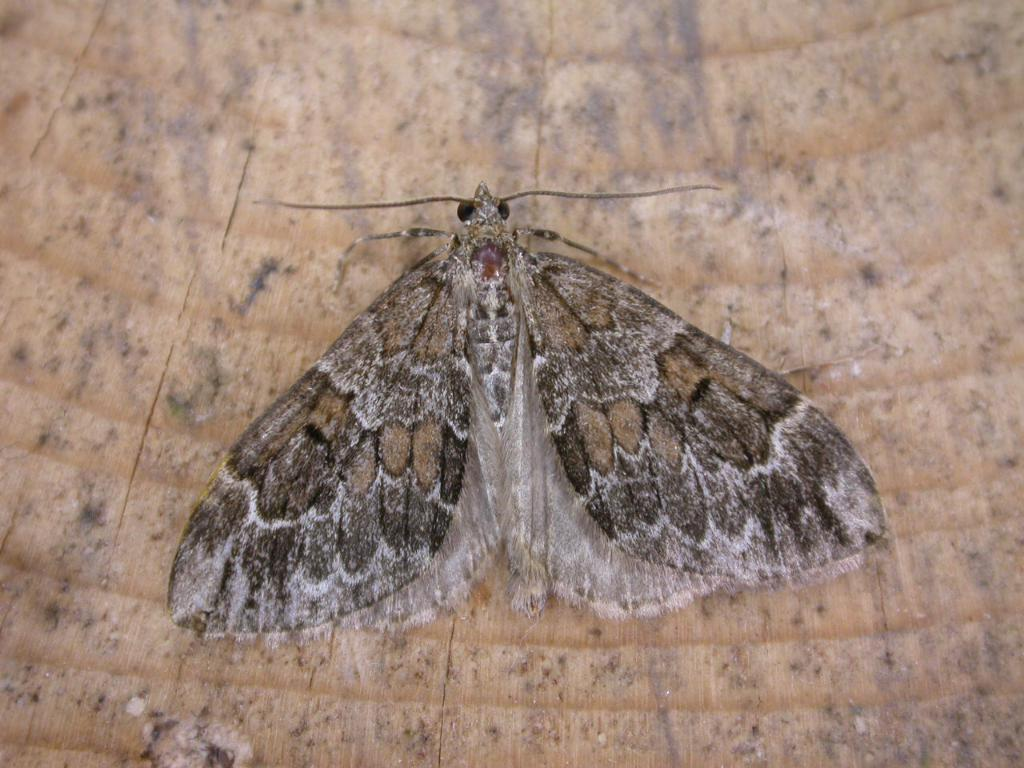What type of creature is in the picture? There is an insect in the picture. What colors can be seen on the insect? The insect has grey, brown, and black colors. What is the insect resting on in the picture? The insect is on a brown surface. What type of hydrant can be seen in the background of the image? There is no hydrant present in the image; it only features an insect on a brown surface. What level of difficulty is the cave in the image rated? There is no cave present in the image, so it cannot be rated for difficulty. 